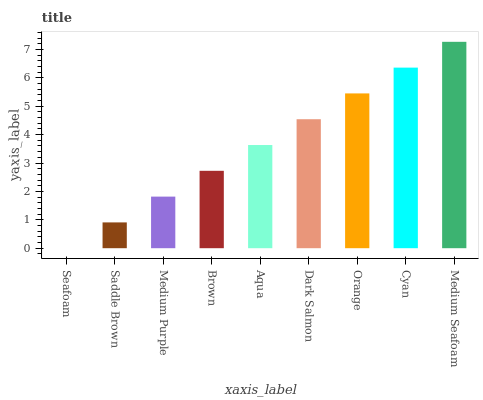Is Seafoam the minimum?
Answer yes or no. Yes. Is Medium Seafoam the maximum?
Answer yes or no. Yes. Is Saddle Brown the minimum?
Answer yes or no. No. Is Saddle Brown the maximum?
Answer yes or no. No. Is Saddle Brown greater than Seafoam?
Answer yes or no. Yes. Is Seafoam less than Saddle Brown?
Answer yes or no. Yes. Is Seafoam greater than Saddle Brown?
Answer yes or no. No. Is Saddle Brown less than Seafoam?
Answer yes or no. No. Is Aqua the high median?
Answer yes or no. Yes. Is Aqua the low median?
Answer yes or no. Yes. Is Medium Seafoam the high median?
Answer yes or no. No. Is Medium Seafoam the low median?
Answer yes or no. No. 